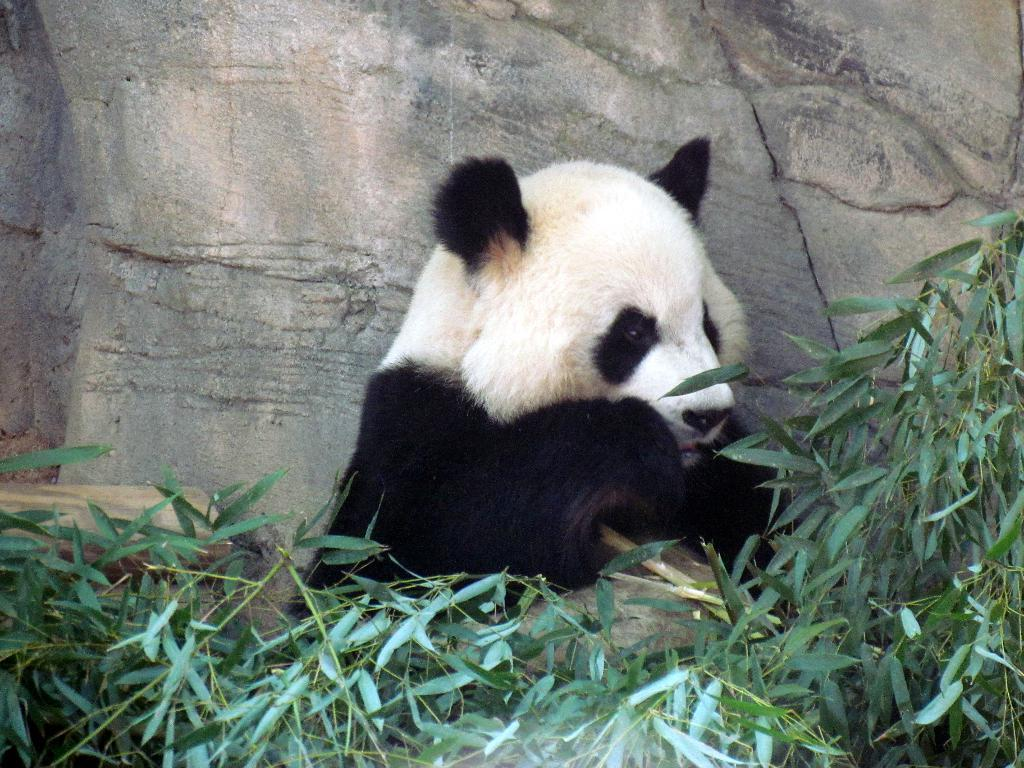What animal is the main subject of the image? There is a panda in the image. What can be seen in front of the panda? There are plants in front of the panda. What is visible in the backdrop of the image? There is a rock in the backdrop of the image. What type of canvas is the panda painting in the image? There is no canvas or painting activity present in the image; it features a panda with plants in front and a rock in the backdrop. Can you tell me how many robins are sitting on the panda's head in the image? There are no robins present in the image; it features a panda with plants in front and a rock in the backdrop. 